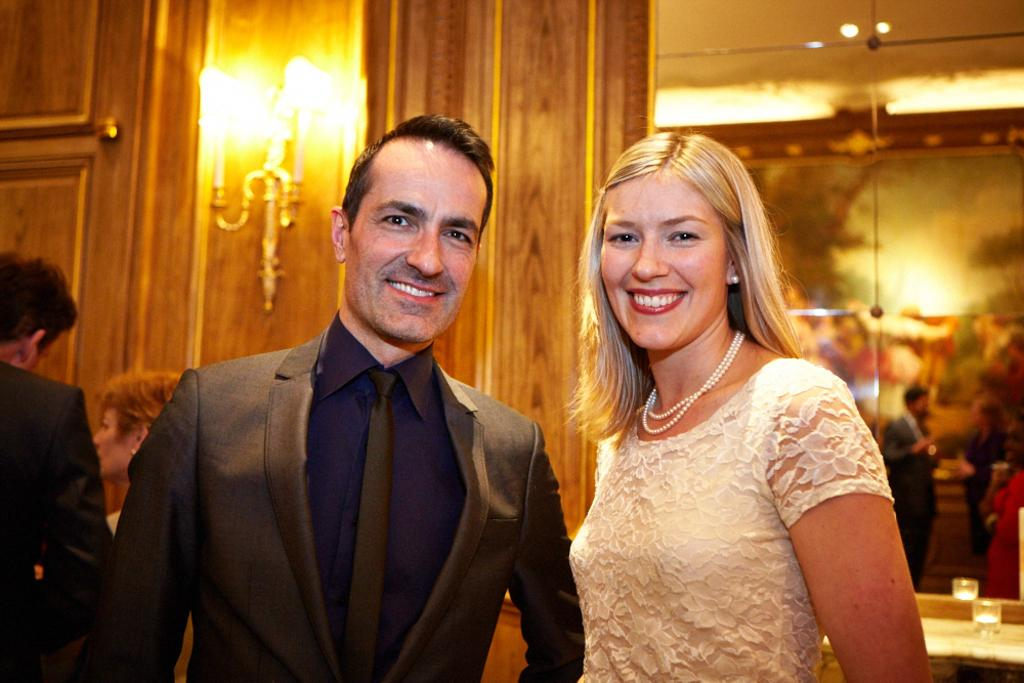Who is present in the image? There is a woman and a man in the image. What are the woman and man doing in the image? The woman and man are watching and smiling. What can be seen in the background of the image? There are people, glass, lights, and showpieces visible in the background of the image. What type of salt is being used to season the food in the image? There is no food or salt present in the image; it features a woman and a man watching and smiling, with a background that includes people, glass, lights, and showpieces. What is the weather like in the image? The provided facts do not mention any information about the weather, so it cannot be determined from the image. 